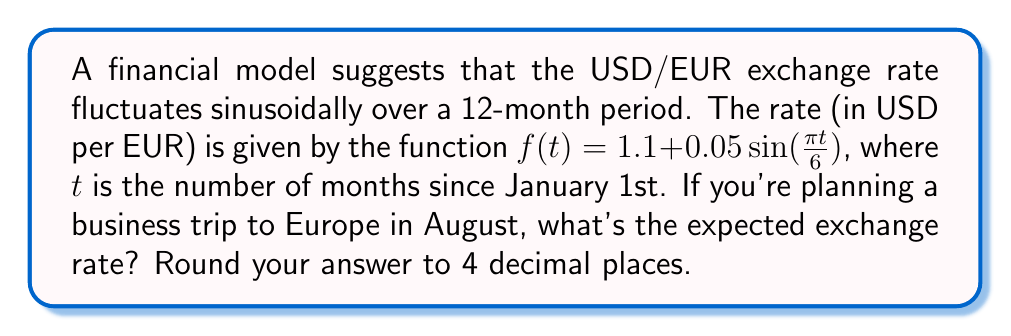Can you solve this math problem? Let's approach this step-by-step:

1) First, we need to determine the value of $t$ for August. Since January is month 0, August would be month 7.

2) Now, we plug $t = 7$ into our function:

   $f(7) = 1.1 + 0.05\sin(\frac{\pi \cdot 7}{6})$

3) Let's calculate the argument of the sine function:
   
   $\frac{\pi \cdot 7}{6} = \frac{7\pi}{6}$

4) Now our equation looks like:

   $f(7) = 1.1 + 0.05\sin(\frac{7\pi}{6})$

5) $\sin(\frac{7\pi}{6}) = -\frac{\sqrt{3}}{2} \approx -0.8660$

6) Plugging this back in:

   $f(7) = 1.1 + 0.05(-0.8660) = 1.1 - 0.0433 = 1.0567$

7) Rounding to 4 decimal places:

   $1.0567 \approx 1.0567$
Answer: $1.0567$ 